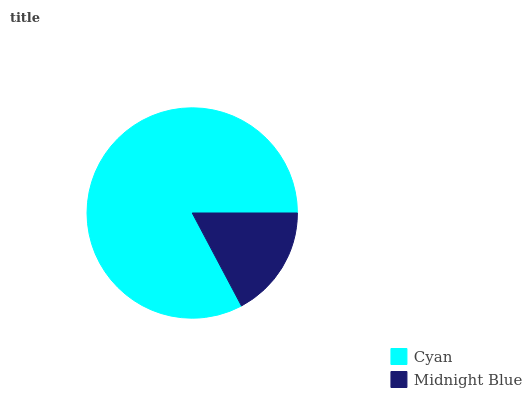Is Midnight Blue the minimum?
Answer yes or no. Yes. Is Cyan the maximum?
Answer yes or no. Yes. Is Midnight Blue the maximum?
Answer yes or no. No. Is Cyan greater than Midnight Blue?
Answer yes or no. Yes. Is Midnight Blue less than Cyan?
Answer yes or no. Yes. Is Midnight Blue greater than Cyan?
Answer yes or no. No. Is Cyan less than Midnight Blue?
Answer yes or no. No. Is Cyan the high median?
Answer yes or no. Yes. Is Midnight Blue the low median?
Answer yes or no. Yes. Is Midnight Blue the high median?
Answer yes or no. No. Is Cyan the low median?
Answer yes or no. No. 